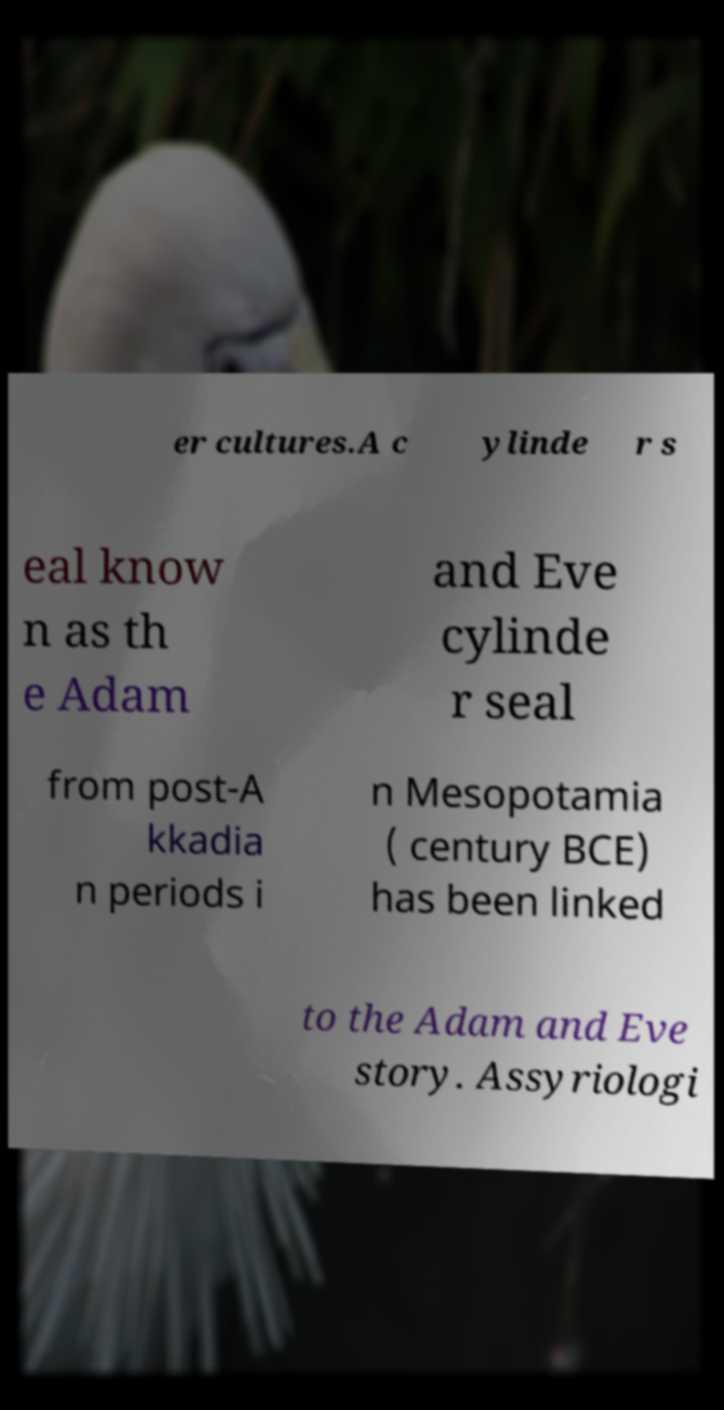Can you accurately transcribe the text from the provided image for me? er cultures.A c ylinde r s eal know n as th e Adam and Eve cylinde r seal from post-A kkadia n periods i n Mesopotamia ( century BCE) has been linked to the Adam and Eve story. Assyriologi 